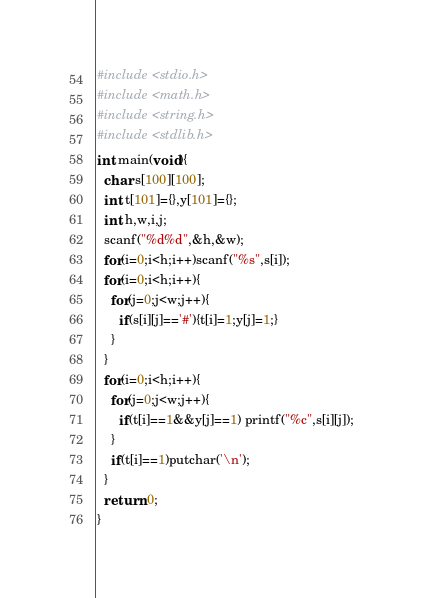Convert code to text. <code><loc_0><loc_0><loc_500><loc_500><_C_>#include <stdio.h>
#include <math.h>
#include <string.h>
#include <stdlib.h>
int main(void){
  char s[100][100];
  int t[101]={},y[101]={};
  int h,w,i,j;
  scanf("%d%d",&h,&w);
  for(i=0;i<h;i++)scanf("%s",s[i]);
  for(i=0;i<h;i++){
    for(j=0;j<w;j++){
      if(s[i][j]=='#'){t[i]=1;y[j]=1;}
    }
  }
  for(i=0;i<h;i++){
    for(j=0;j<w;j++){
      if(t[i]==1&&y[j]==1) printf("%c",s[i][j]);
    }
    if(t[i]==1)putchar('\n');
  }
  return 0;
}</code> 